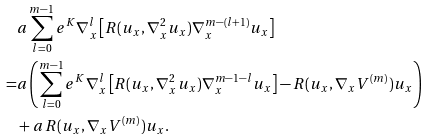<formula> <loc_0><loc_0><loc_500><loc_500>& a \sum _ { l = 0 } ^ { m - 1 } e ^ { K } \nabla _ { x } ^ { l } \left [ R ( u _ { x } , \nabla _ { x } ^ { 2 } u _ { x } ) \nabla _ { x } ^ { m - ( l + 1 ) } u _ { x } \right ] \\ = & a \left ( \sum _ { l = 0 } ^ { m - 1 } e ^ { K } \nabla _ { x } ^ { l } \left [ R ( u _ { x } , \nabla _ { x } ^ { 2 } u _ { x } ) \nabla _ { x } ^ { m - 1 - l } u _ { x } \right ] - R ( u _ { x } , \nabla _ { x } V ^ { ( m ) } ) u _ { x } \right ) \\ & + a \, R ( u _ { x } , \nabla _ { x } V ^ { ( m ) } ) u _ { x } .</formula> 